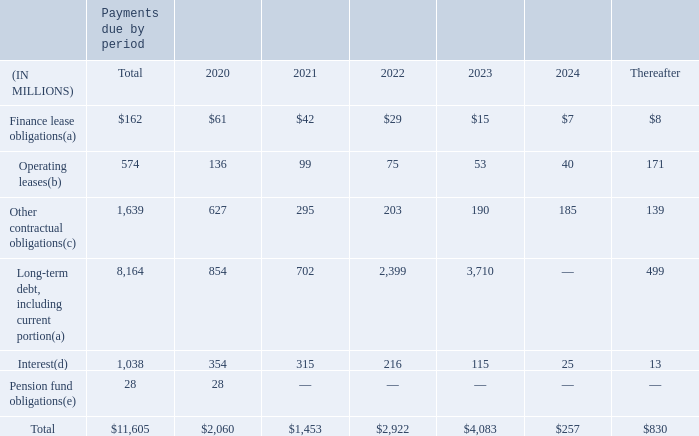Other Contractual Obligations
Our other contractual obligations include finance lease obligations (including interest portion), facility leases, leases of certain computer and other equipment, agreements to purchase data and telecommunication services, the payment of principal and interest on debt and pension fund obligations.
At December 31, 2019, the minimum annual payments under these agreements and other contracts that had initial or remaining non-cancelable terms in excess of one year are as listed in the following table. Due to the uncertainty with respect to the timing of future cash flows associated with our unrecognized tax positions at December 31, 2019, we are unable to make reasonably reliable estimates of the timing of any potential cash settlements with the respective taxing authorities. Therefore, $189 million in uncertain tax positions (which includes interest and penalties of $25 million) have been excluded from the contractual obligations table below. See Note 15 – “Income Taxes” – to the consolidated financial statements for a discussion on income taxes.
(a) Our short-term and long-term debt obligations are described in Note 12 – “Long-Term Debt and Other Financing Arrangements” and our short-term and long-term finance lease obligations are described in Note 5 “Leases”,– to our consolidated financial statements.
(b) Our operating lease obligations are described in Note 17 – “Commitments and Contingencies” – to our consolidated financial statements.
What do the other contractual obligations include? Finance lease obligations (including interest portion), facility leases, leases of certain computer and other equipment, agreements to purchase data and telecommunication services, the payment of principal and interest on debt and pension fund obligations. What is the total amount of finance lease obligations?
Answer scale should be: million. $162. What is the total amount of payments due?
Answer scale should be: million. 11,605. What is the percentage of total pension fund obligations in the total amount of payments due?
Answer scale should be: percent. 28/11,605
Answer: 0.24. What is the percentage constitution of amount of finance lease obligations due in 2024 among the total amount?
Answer scale should be: percent. 7/162
Answer: 4.32. What is the difference between the total payment for operating leases and finance lease obligations?
Answer scale should be: million. 574-162
Answer: 412. 